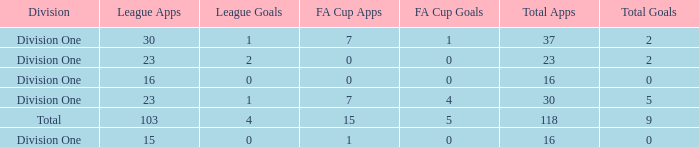The total goals have a FA Cup Apps larger than 1, and a Total Apps of 37, and a League Apps smaller than 30?, what is the total number? 0.0. 